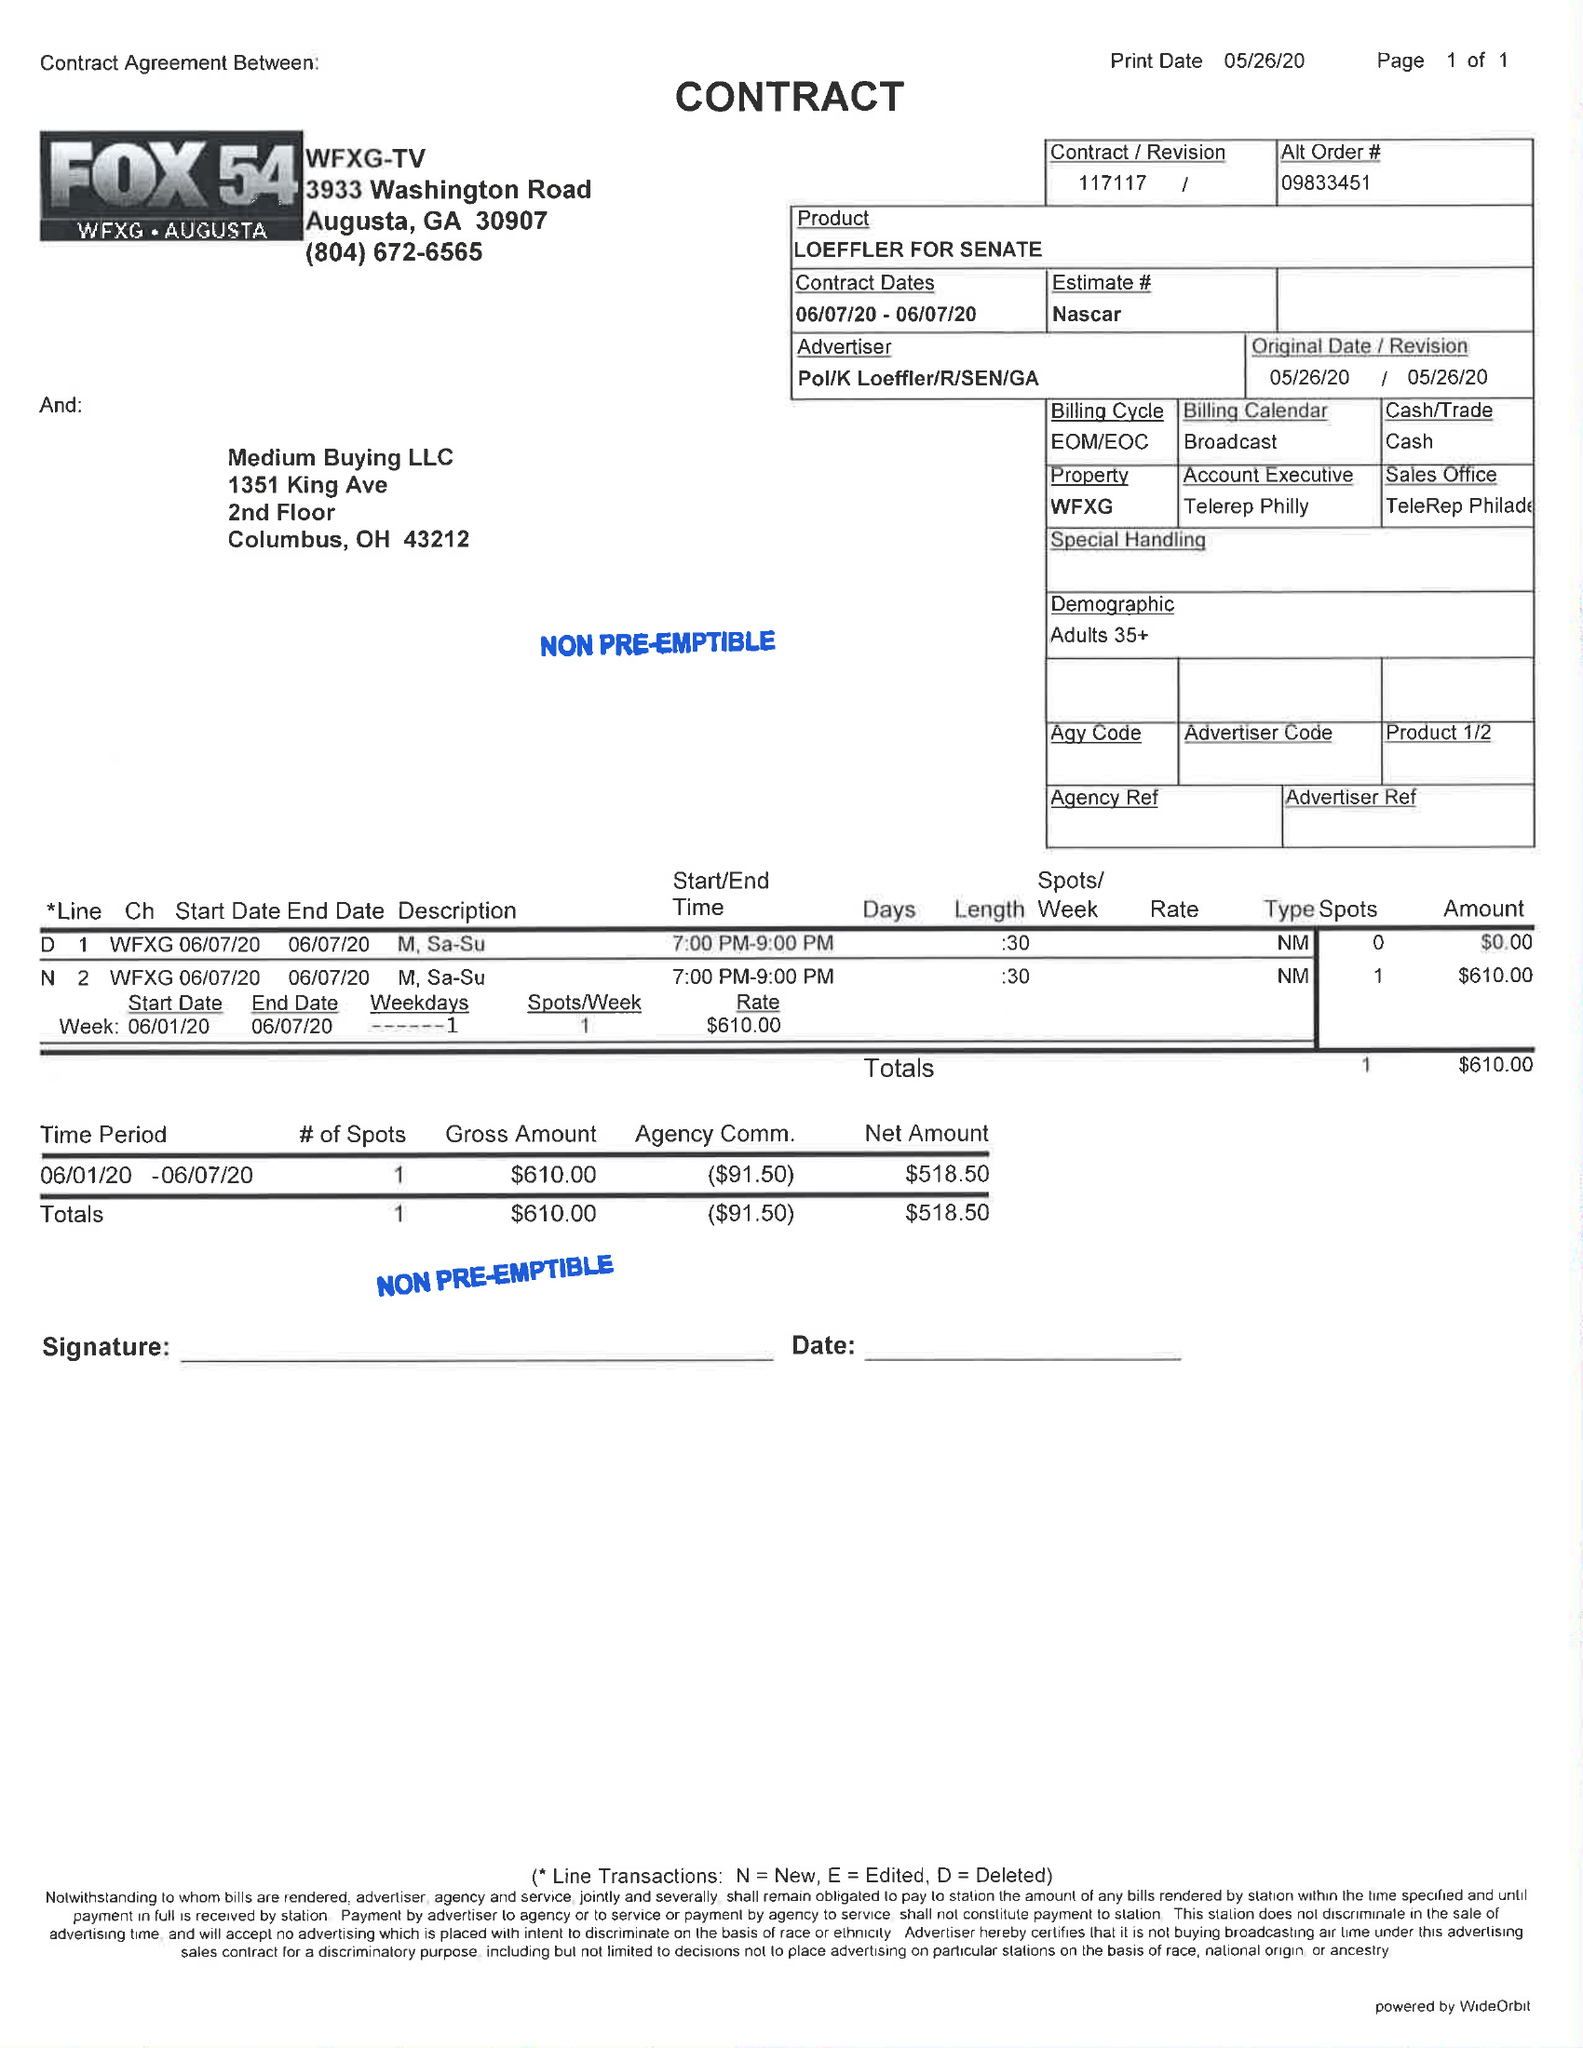What is the value for the contract_num?
Answer the question using a single word or phrase. 117117 